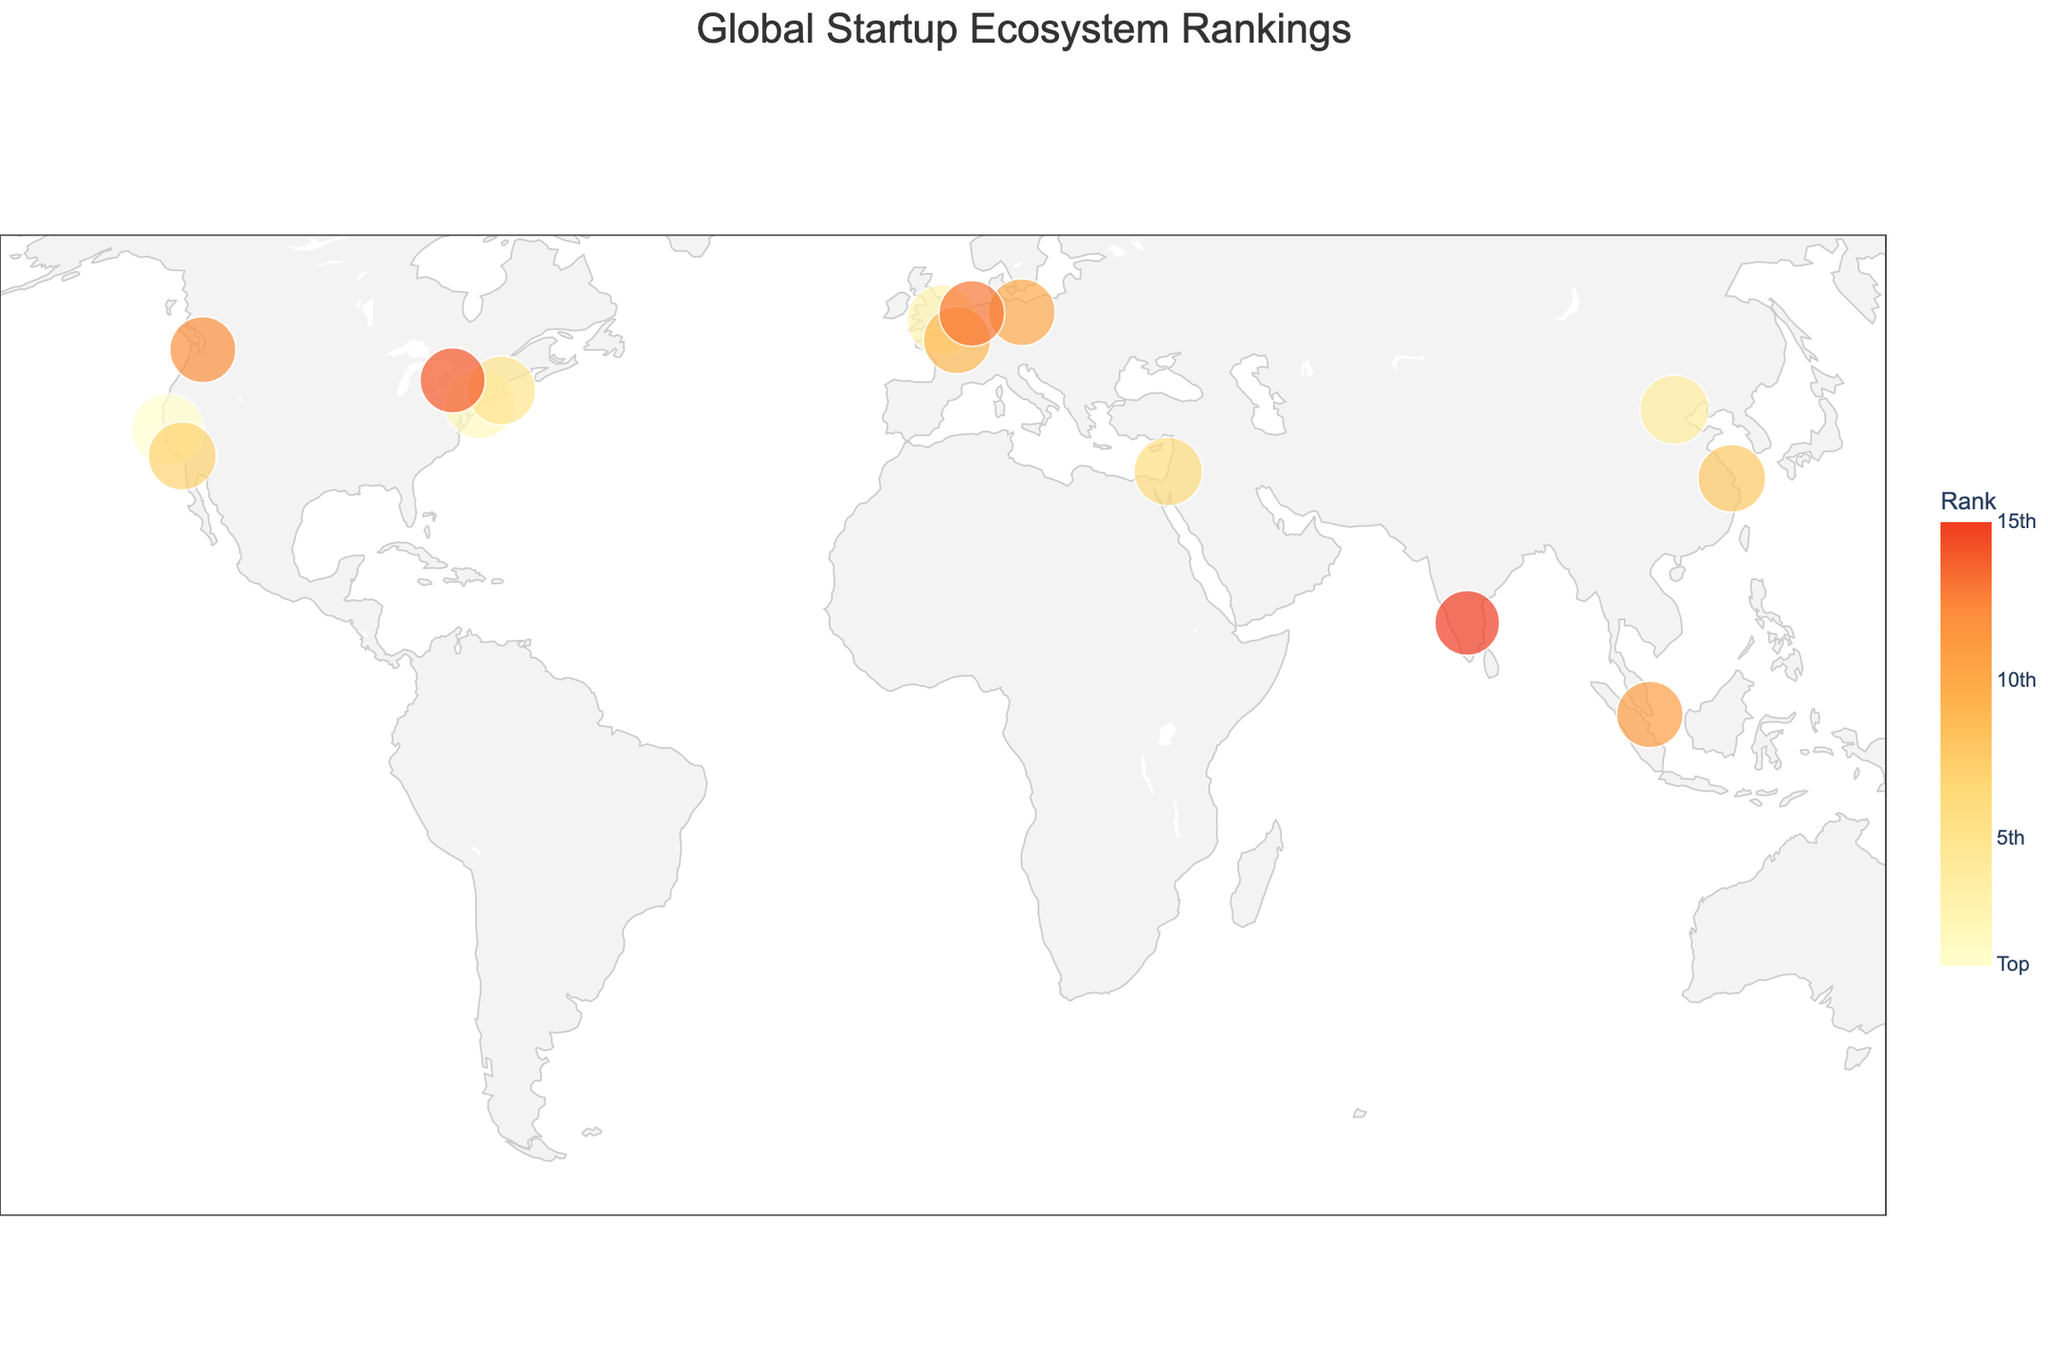what is the title of the plot? The title is displayed at the top center of the plot. It reads "Global Startup Ecosystem Rankings".
Answer: Global Startup Ecosystem Rankings Which city has the highest Startup Ecosystem Rank? To find the city with the highest rank, we look for the rank value of 1 on the color legend and locate the corresponding city label on the plot. The city with the highest rank is Silicon Valley.
Answer: Silicon Valley What is the investment score for New York City? To find this, hover over New York City on the plot, and the tooltip shows relevant information including the Investment Score. The Investment Score for New York City is 92.
Answer: 92 How many cities in total are shown on the plot? Counting each data point on the plot or counting the number of rows in the provided data will give the total number of cities. There are 15 cities shown.
Answer: 15 Which city has both the highest Innovation Score and a rank among the top 5? From the top 5 ranked cities (Silicon Valley, New York City, London, Beijing, Boston), compare their innovation scores. Silicon Valley has the highest Innovation Score of 98.
Answer: Silicon Valley Compare the investment scores of Paris and Berlin. Which city has a higher score? Locate Paris and Berlin on the plot and compare their Investment Scores shown in the hover data. Paris has a score of 83, while Berlin has a score of 82. Thus, Paris has a higher investment score.
Answer: Paris Identify the city in Asia with the highest Startup Ecosystem Rank. From the list of cities, filter out the Asian cities and compare their ranks. Beijing has the highest Startup Ecosystem Rank among the Asian cities with a rank of 4.
Answer: Beijing What is the average Investment Score for the top 3 ranked cities? Add the Investment Scores for Silicon Valley (95), New York City (92), and London (90), and then divide by 3. The average is (95 + 92 + 90) / 3 = 92.33.
Answer: 92.33 Are there any cities from the Southern Hemisphere in the plot? Examine the latitudes of all the cities. None of the cities listed have latitudes that indicate they are in the Southern Hemisphere (below the equator).
Answer: No What is the latitude and longitude of the city ranked 10th in the Startup Ecosystem? Look up the 10th ranked city, which is Berlin, and check its latitude and longitude from the data table. The latitude is 52.5200, and the longitude is 13.4050.
Answer: 52.5200, 13.4050 